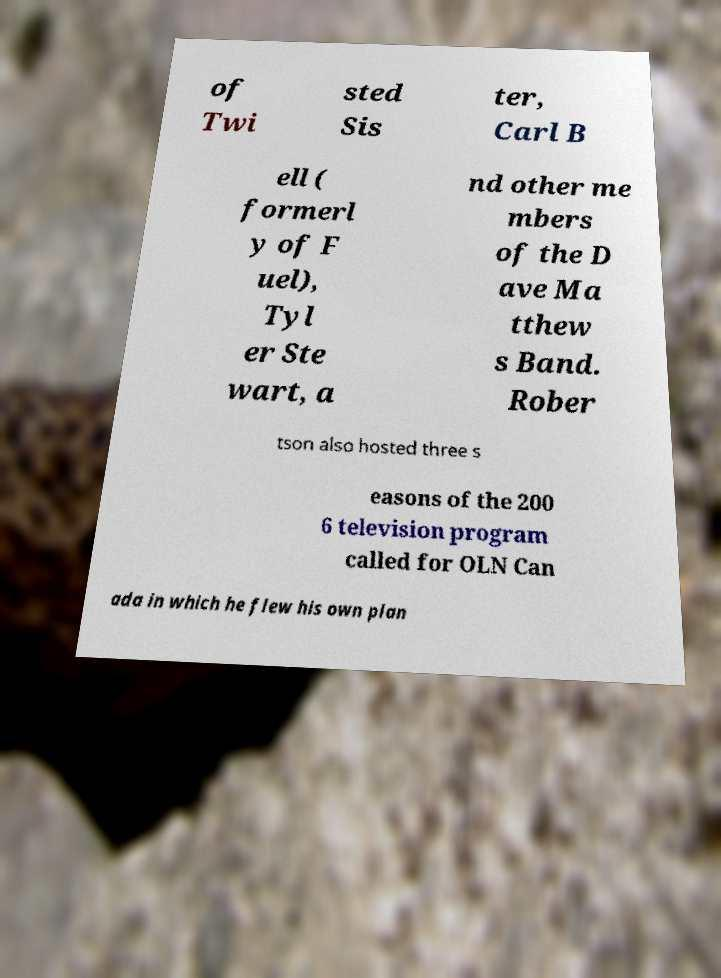Can you read and provide the text displayed in the image?This photo seems to have some interesting text. Can you extract and type it out for me? of Twi sted Sis ter, Carl B ell ( formerl y of F uel), Tyl er Ste wart, a nd other me mbers of the D ave Ma tthew s Band. Rober tson also hosted three s easons of the 200 6 television program called for OLN Can ada in which he flew his own plan 